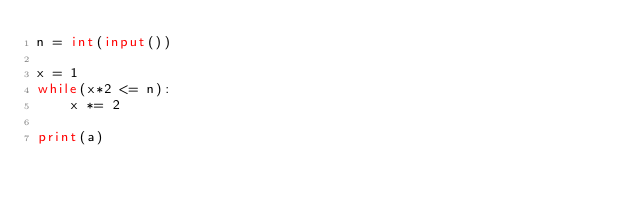Convert code to text. <code><loc_0><loc_0><loc_500><loc_500><_Python_>n = int(input())

x = 1
while(x*2 <= n):
    x *= 2

print(a)</code> 